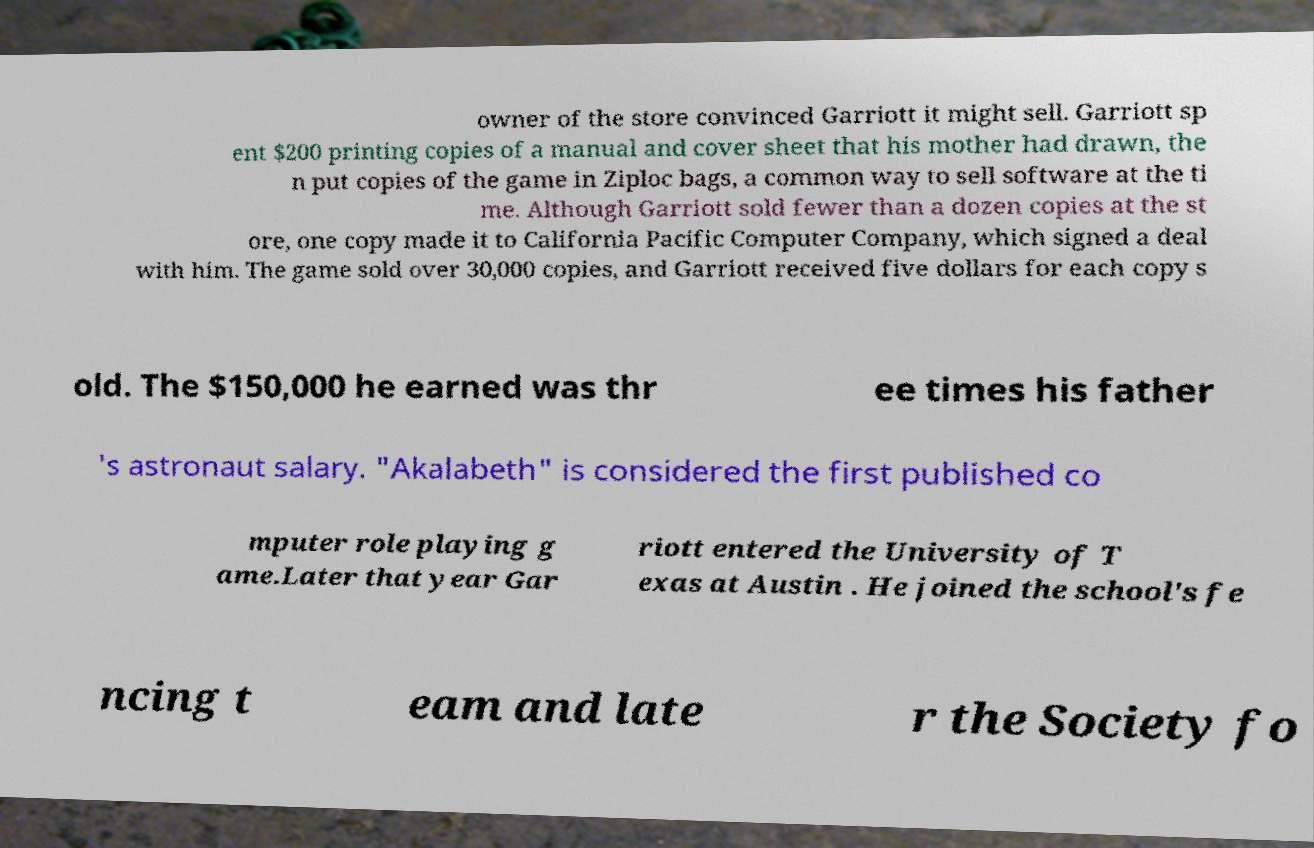What messages or text are displayed in this image? I need them in a readable, typed format. owner of the store convinced Garriott it might sell. Garriott sp ent $200 printing copies of a manual and cover sheet that his mother had drawn, the n put copies of the game in Ziploc bags, a common way to sell software at the ti me. Although Garriott sold fewer than a dozen copies at the st ore, one copy made it to California Pacific Computer Company, which signed a deal with him. The game sold over 30,000 copies, and Garriott received five dollars for each copy s old. The $150,000 he earned was thr ee times his father 's astronaut salary. "Akalabeth" is considered the first published co mputer role playing g ame.Later that year Gar riott entered the University of T exas at Austin . He joined the school's fe ncing t eam and late r the Society fo 